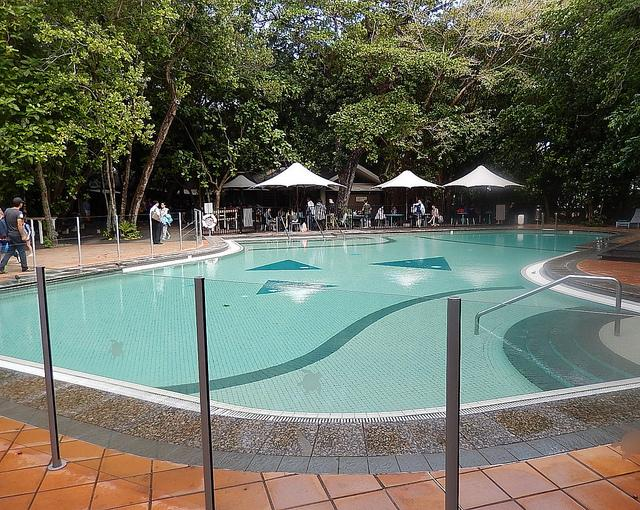What is the far end of the pool called? deep end 